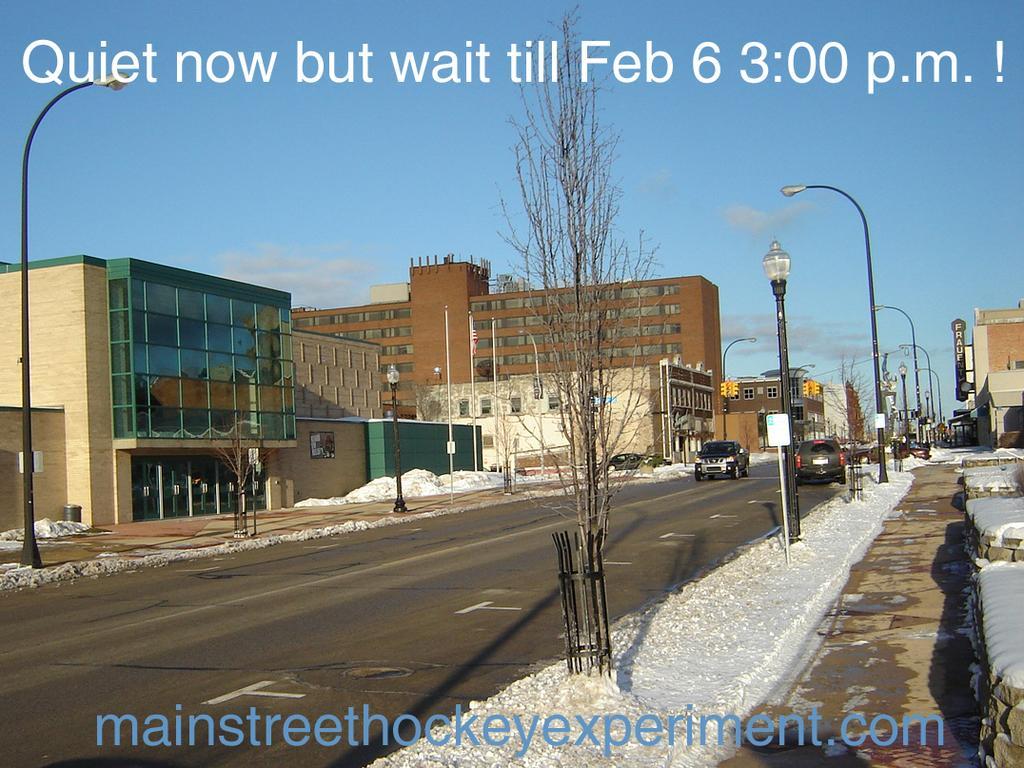Could you give a brief overview of what you see in this image? In this picture I can see vehicles on the road, there are poles, lights, boards, there is snow, there are buildings, trees, and in the background there is sky and there are watermarks on the image. 